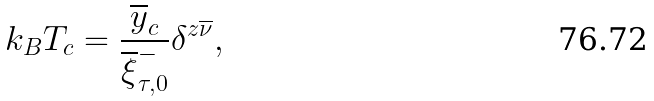Convert formula to latex. <formula><loc_0><loc_0><loc_500><loc_500>k _ { B } T _ { c } = \frac { \overline { y } _ { c } } { \overline { \xi } _ { \tau , 0 } ^ { - } } \delta ^ { z \overline { \nu } } ,</formula> 